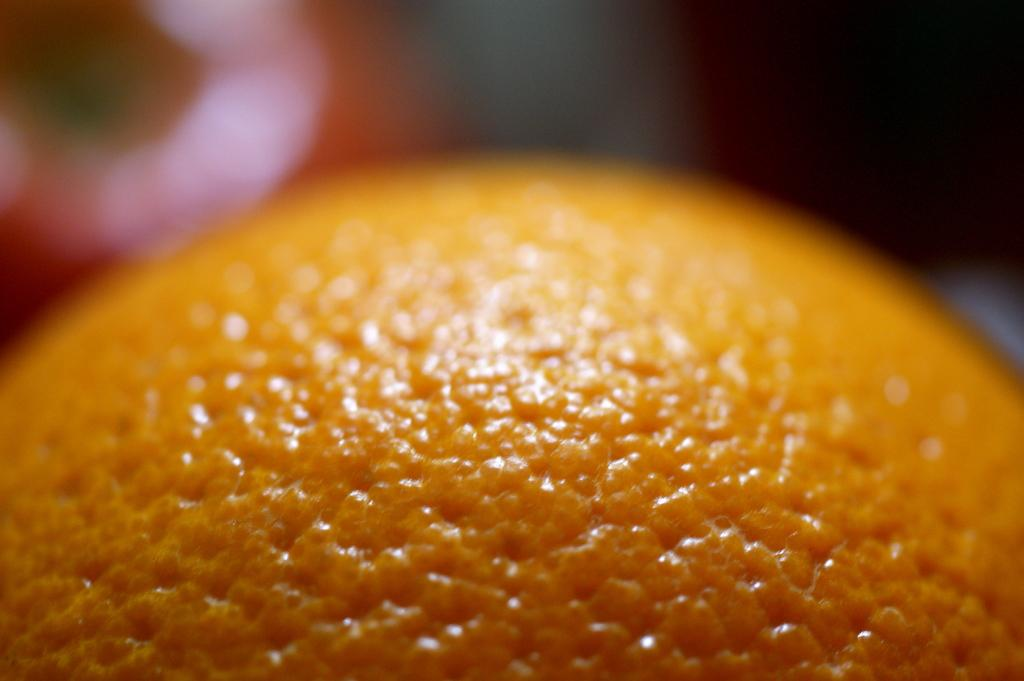What fruit is present in the image? There is an orange in the image. Can you describe the top part of the image? The top of the image has a blurry view. What type of card is visible in the image? There is no card present in the image; it only features an orange and a blurry view at the top. 